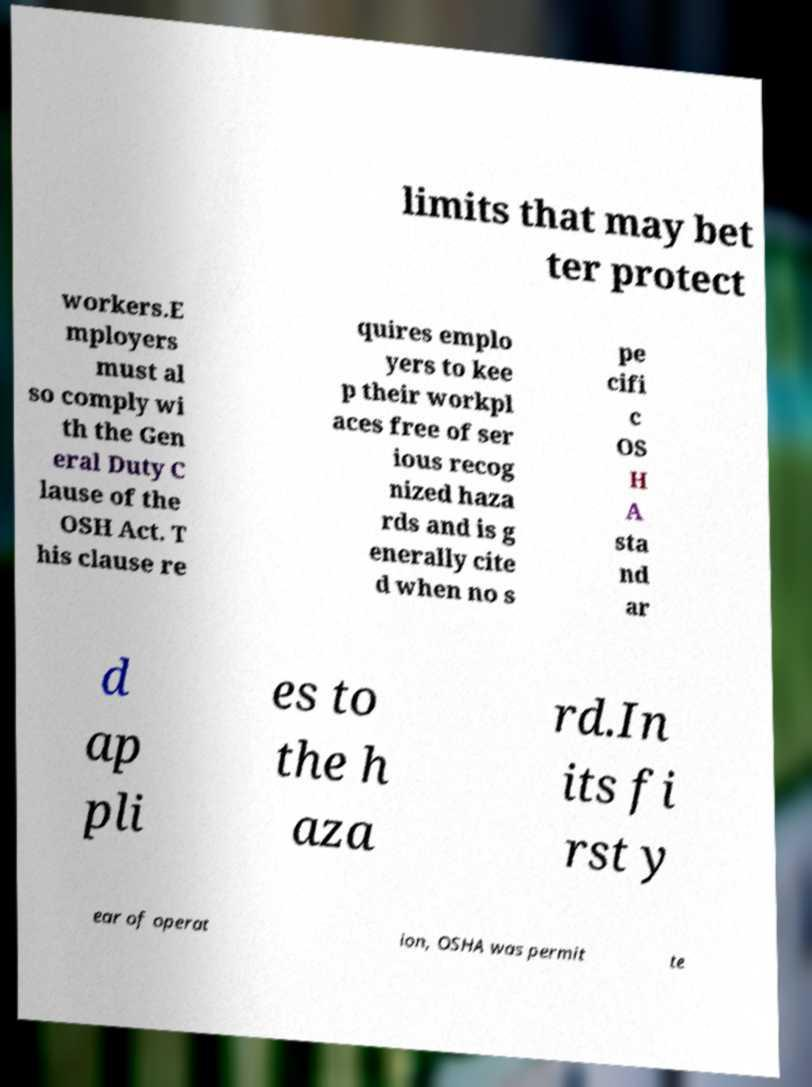Could you assist in decoding the text presented in this image and type it out clearly? limits that may bet ter protect workers.E mployers must al so comply wi th the Gen eral Duty C lause of the OSH Act. T his clause re quires emplo yers to kee p their workpl aces free of ser ious recog nized haza rds and is g enerally cite d when no s pe cifi c OS H A sta nd ar d ap pli es to the h aza rd.In its fi rst y ear of operat ion, OSHA was permit te 